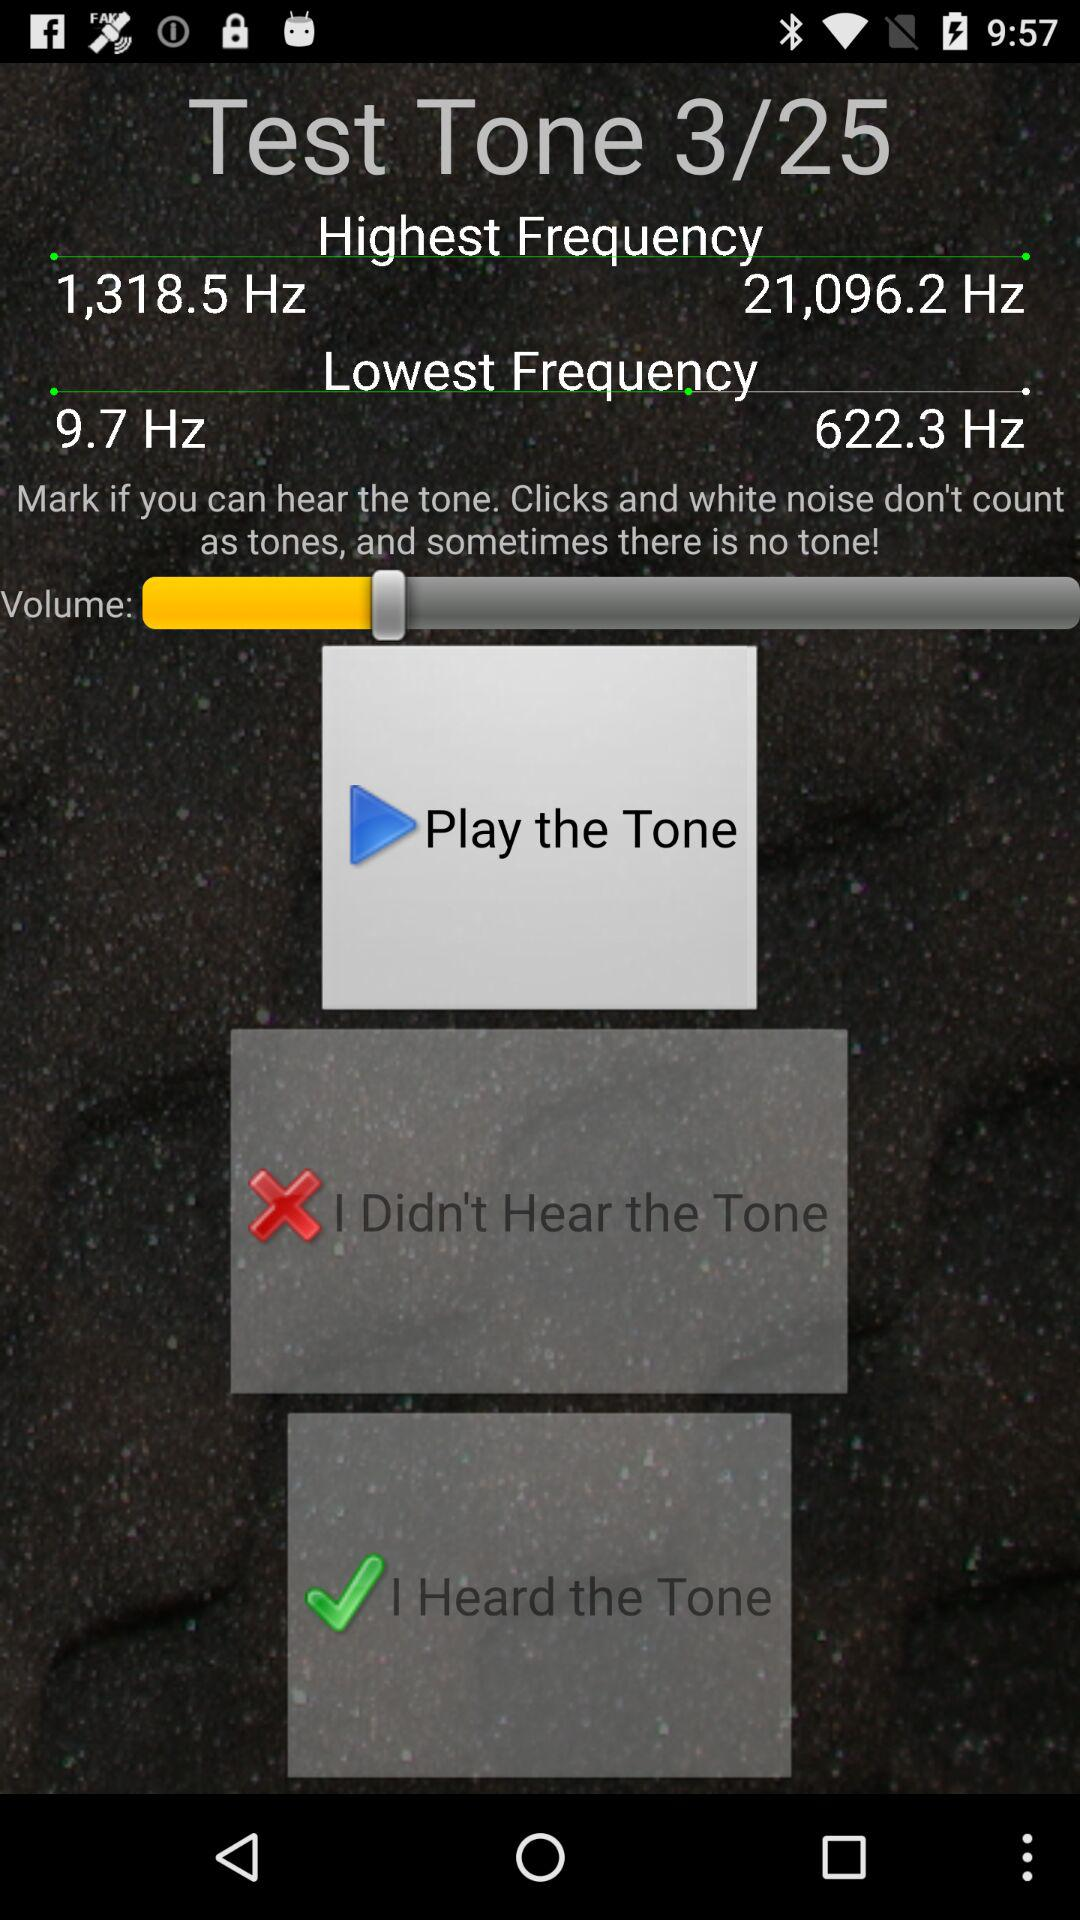What is the lowest frequency? The lowest frequencies are 9.7 Hz and 622.3 Hz. 